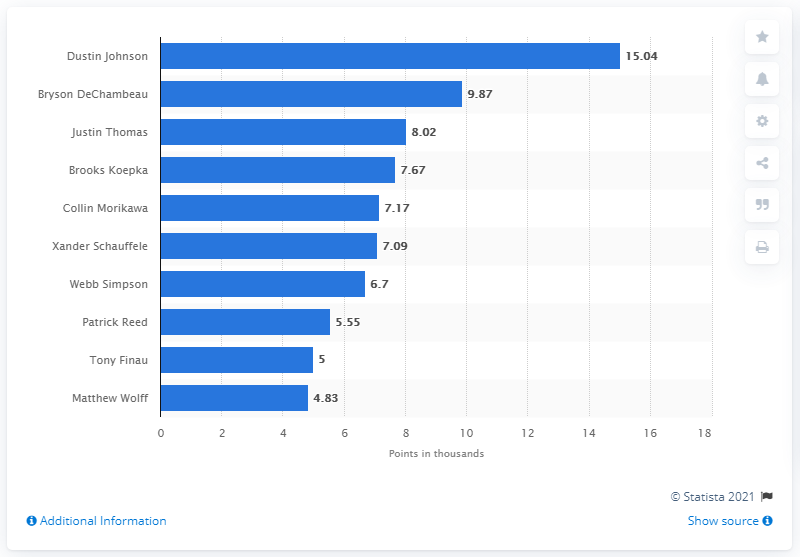Mention a couple of crucial points in this snapshot. Dustin Johnson, ranked among the top 10 professional golfers, has accrued the most Ryder Cup points among his peers. 